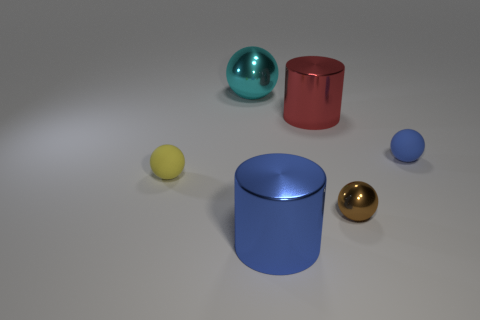Add 3 tiny brown objects. How many objects exist? 9 Subtract all spheres. How many objects are left? 2 Subtract all blue cylinders. Subtract all small yellow balls. How many objects are left? 4 Add 4 large shiny spheres. How many large shiny spheres are left? 5 Add 1 blue metal objects. How many blue metal objects exist? 2 Subtract 0 purple cylinders. How many objects are left? 6 